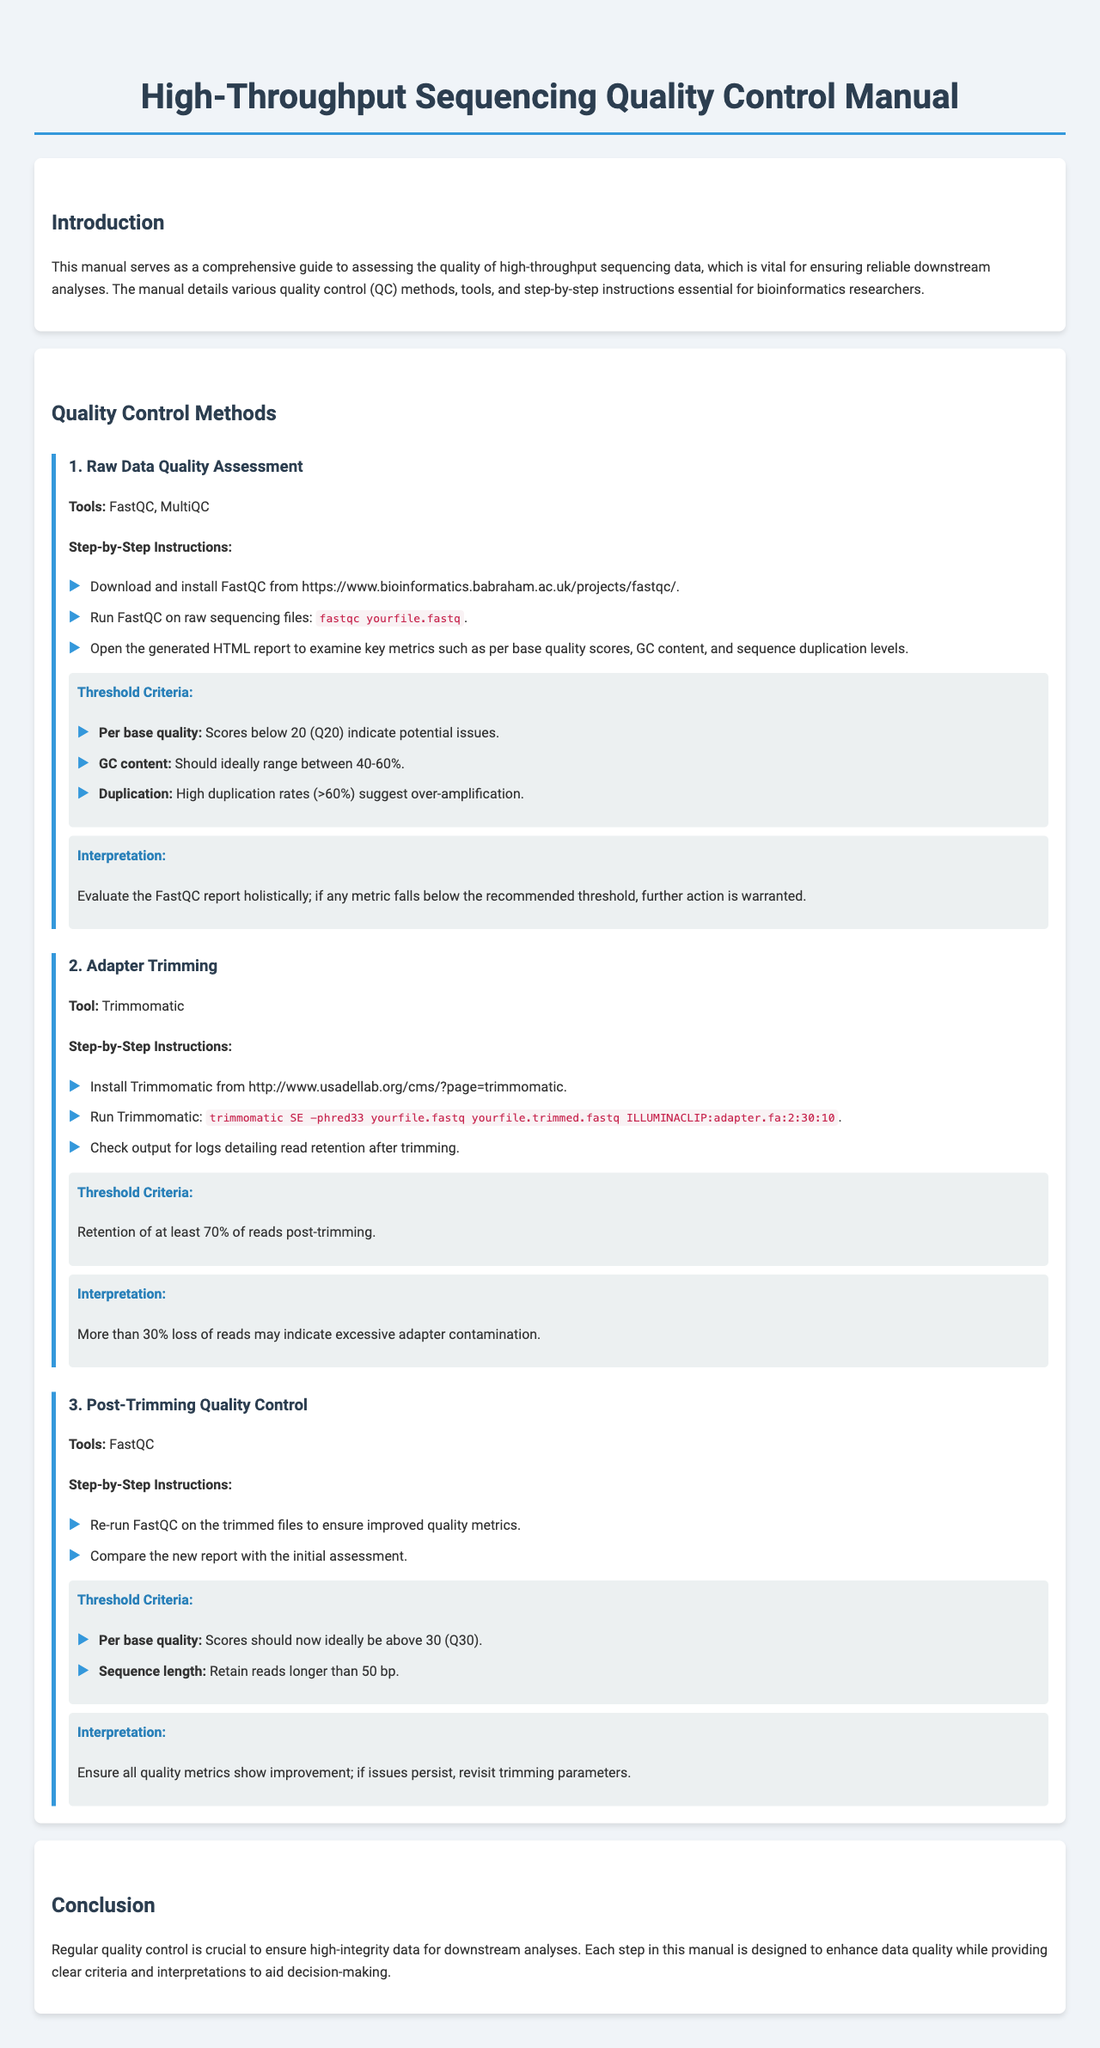What is the primary purpose of the manual? The manual serves as a comprehensive guide to assessing the quality of high-throughput sequencing data.
Answer: Quality assessment Which tool is used for raw data quality assessment? FastQC is mentioned as a tool for raw data quality assessment.
Answer: FastQC What is the threshold criteria for per base quality in Raw Data Quality Assessment? Scores below 20 (Q20) indicate potential issues according to the threshold criteria.
Answer: 20 What should the GC content ideally range between? The document states that GC content should ideally range between 40-60%.
Answer: 40-60% What percentage of reads should be retained post-trimming according to the Adapter Trimming section? The threshold criteria specify retention of at least 70% of reads post-trimming.
Answer: 70% What is considered excessive adapter contamination in the Adapter Trimming section? More than 30% loss of reads may indicate excessive adapter contamination.
Answer: 30% What is the ideal per base quality score after trimming? It is mentioned that scores should ideally be above 30 (Q30) after trimming.
Answer: 30 How should the quality metrics behave after post-trimming quality control? The document suggests ensuring all quality metrics show improvement.
Answer: Improvement What is the main focus of this Quality Control Manual? The manual focuses on quality control for high-throughput sequencing data.
Answer: Quality control 